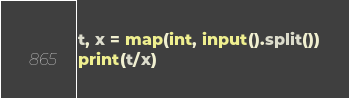Convert code to text. <code><loc_0><loc_0><loc_500><loc_500><_Python_>t, x = map(int, input().split())
print(t/x)
</code> 